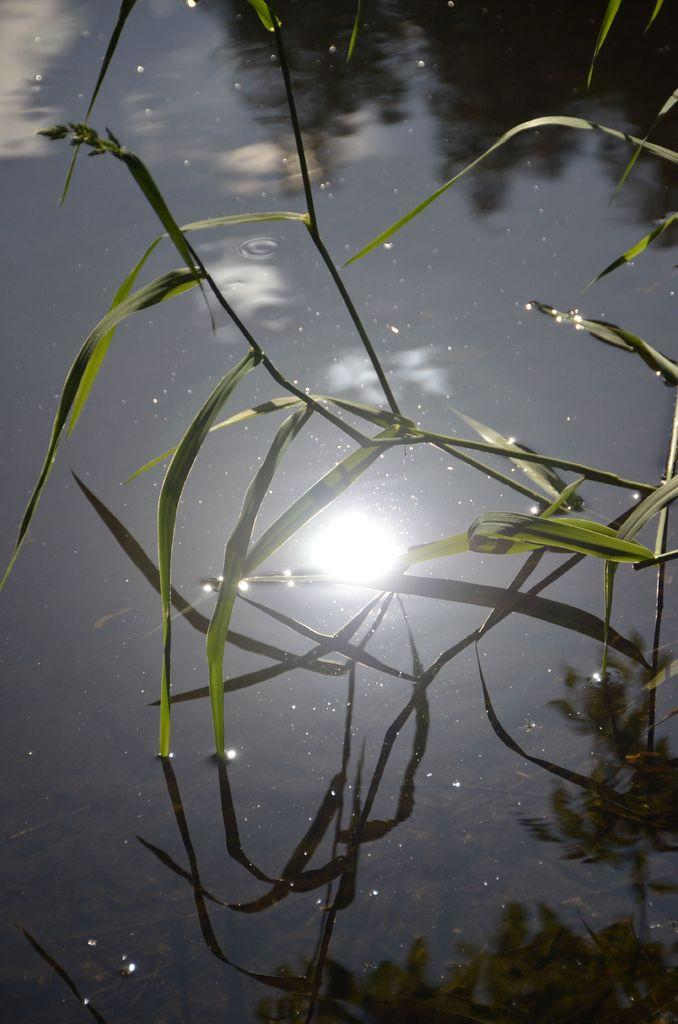What type of vegetation is present in the image? There is grass in the image. What can be seen in the water in the image? There is a reflection of trees and the sky in the water. What type of snow can be seen falling in the image? There is no snow present in the image; it features grass, a reflection of trees, and a reflection of the sky in the water. 